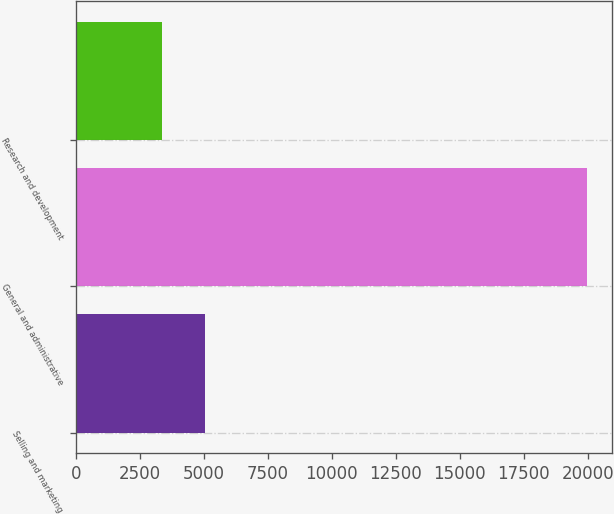Convert chart. <chart><loc_0><loc_0><loc_500><loc_500><bar_chart><fcel>Selling and marketing<fcel>General and administrative<fcel>Research and development<nl><fcel>5042<fcel>19963<fcel>3345<nl></chart> 